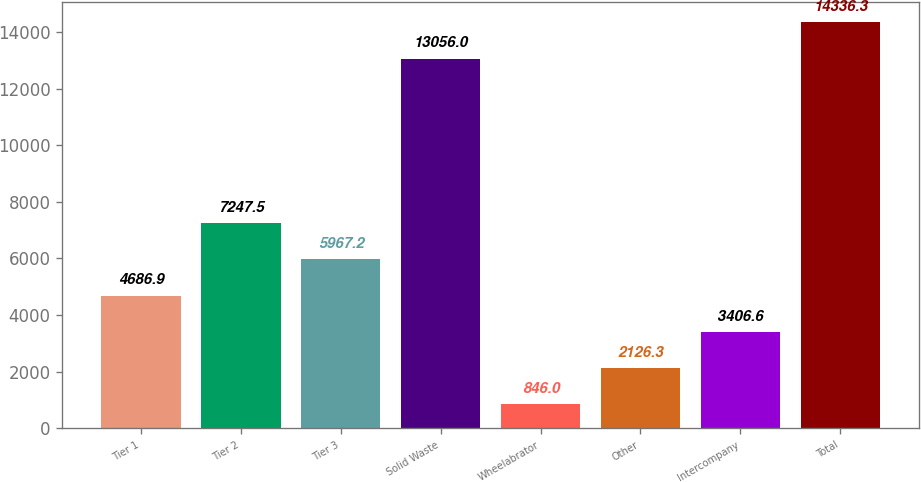Convert chart to OTSL. <chart><loc_0><loc_0><loc_500><loc_500><bar_chart><fcel>Tier 1<fcel>Tier 2<fcel>Tier 3<fcel>Solid Waste<fcel>Wheelabrator<fcel>Other<fcel>Intercompany<fcel>Total<nl><fcel>4686.9<fcel>7247.5<fcel>5967.2<fcel>13056<fcel>846<fcel>2126.3<fcel>3406.6<fcel>14336.3<nl></chart> 